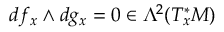<formula> <loc_0><loc_0><loc_500><loc_500>d f _ { x } \wedge d g _ { x } = 0 \in \Lambda ^ { 2 } ( T _ { x } ^ { * } M )</formula> 